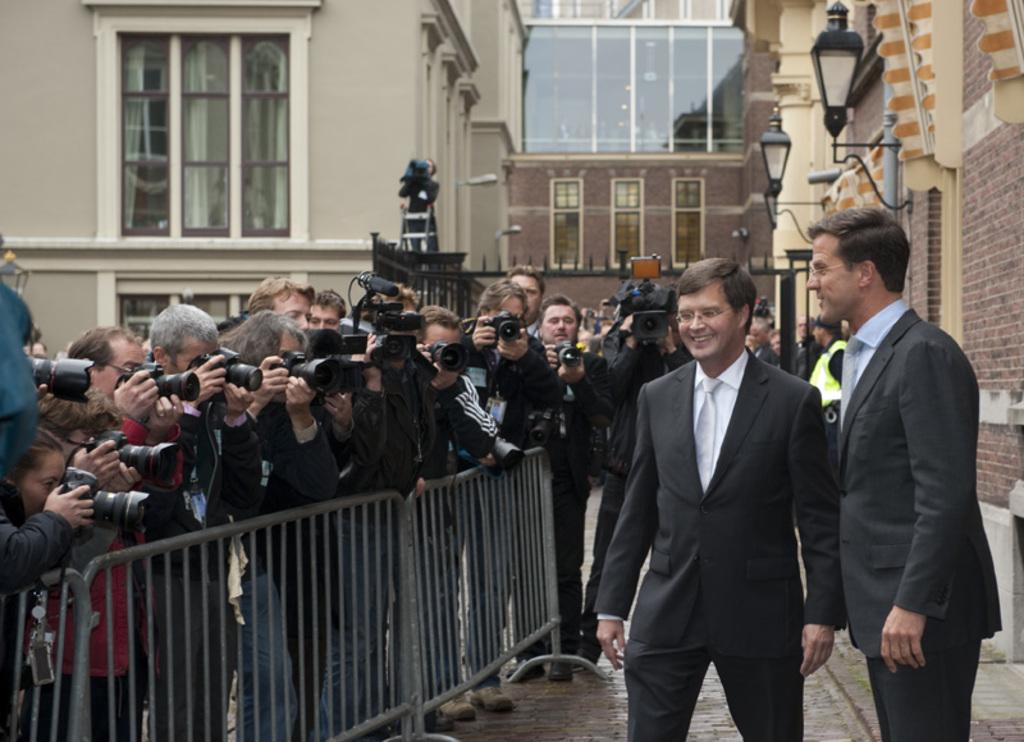What is the main subject of the image? The main subject of the image is a group of people. What are some of the people in the group doing? Some people in the group are holding cameras. What can be seen in the background of the image? There are lights and buildings visible in the background of the image. What type of celery can be seen growing in the image? There is no celery present in the image. How many boys are visible in the image? The provided facts do not mention the gender of the people in the image, so it cannot be determined if there are any boys present. 